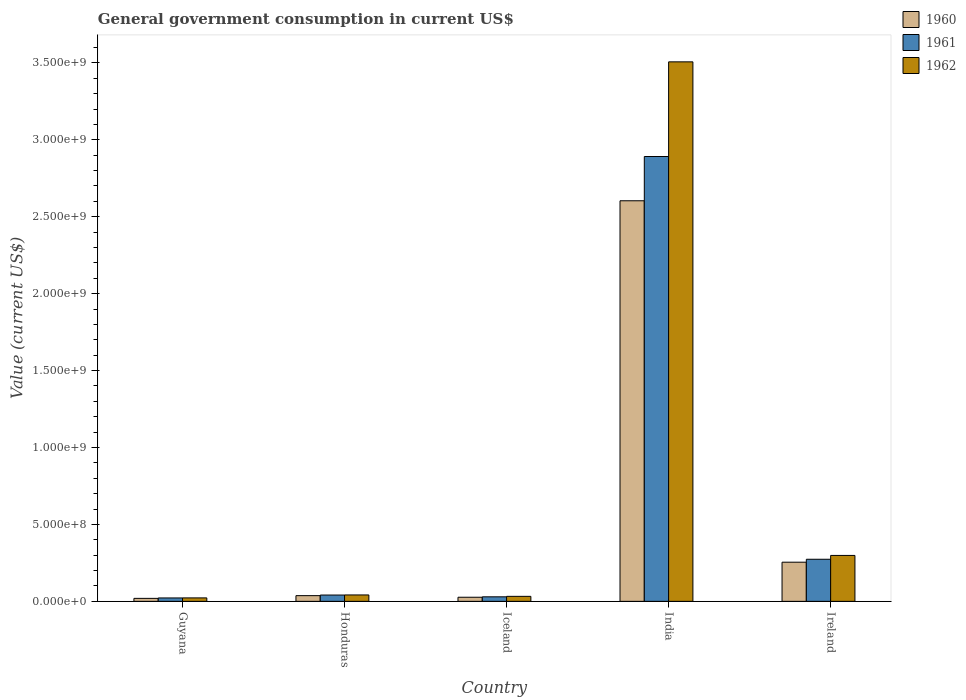How many different coloured bars are there?
Your answer should be compact. 3. Are the number of bars per tick equal to the number of legend labels?
Offer a terse response. Yes. How many bars are there on the 3rd tick from the left?
Your response must be concise. 3. How many bars are there on the 1st tick from the right?
Provide a succinct answer. 3. What is the government conusmption in 1961 in Ireland?
Your answer should be very brief. 2.74e+08. Across all countries, what is the maximum government conusmption in 1962?
Make the answer very short. 3.51e+09. Across all countries, what is the minimum government conusmption in 1962?
Your answer should be compact. 2.25e+07. In which country was the government conusmption in 1960 minimum?
Provide a succinct answer. Guyana. What is the total government conusmption in 1961 in the graph?
Keep it short and to the point. 3.26e+09. What is the difference between the government conusmption in 1961 in Iceland and that in India?
Your answer should be very brief. -2.86e+09. What is the difference between the government conusmption in 1961 in India and the government conusmption in 1960 in Honduras?
Keep it short and to the point. 2.85e+09. What is the average government conusmption in 1961 per country?
Your answer should be very brief. 6.52e+08. What is the difference between the government conusmption of/in 1960 and government conusmption of/in 1961 in Ireland?
Keep it short and to the point. -1.91e+07. In how many countries, is the government conusmption in 1960 greater than 2300000000 US$?
Provide a short and direct response. 1. What is the ratio of the government conusmption in 1962 in Iceland to that in India?
Keep it short and to the point. 0.01. Is the difference between the government conusmption in 1960 in Guyana and Iceland greater than the difference between the government conusmption in 1961 in Guyana and Iceland?
Give a very brief answer. Yes. What is the difference between the highest and the second highest government conusmption in 1962?
Provide a succinct answer. 2.57e+08. What is the difference between the highest and the lowest government conusmption in 1962?
Your answer should be very brief. 3.48e+09. Is the sum of the government conusmption in 1961 in Honduras and Ireland greater than the maximum government conusmption in 1960 across all countries?
Your answer should be very brief. No. What does the 3rd bar from the right in Ireland represents?
Your answer should be very brief. 1960. Is it the case that in every country, the sum of the government conusmption in 1961 and government conusmption in 1960 is greater than the government conusmption in 1962?
Provide a succinct answer. Yes. How many bars are there?
Offer a very short reply. 15. Are all the bars in the graph horizontal?
Provide a succinct answer. No. Are the values on the major ticks of Y-axis written in scientific E-notation?
Give a very brief answer. Yes. Does the graph contain grids?
Give a very brief answer. No. Where does the legend appear in the graph?
Provide a succinct answer. Top right. What is the title of the graph?
Give a very brief answer. General government consumption in current US$. What is the label or title of the X-axis?
Your response must be concise. Country. What is the label or title of the Y-axis?
Give a very brief answer. Value (current US$). What is the Value (current US$) of 1960 in Guyana?
Your answer should be very brief. 1.95e+07. What is the Value (current US$) in 1961 in Guyana?
Provide a succinct answer. 2.22e+07. What is the Value (current US$) in 1962 in Guyana?
Your answer should be compact. 2.25e+07. What is the Value (current US$) in 1960 in Honduras?
Your answer should be compact. 3.72e+07. What is the Value (current US$) in 1961 in Honduras?
Your answer should be very brief. 4.10e+07. What is the Value (current US$) of 1962 in Honduras?
Make the answer very short. 4.16e+07. What is the Value (current US$) in 1960 in Iceland?
Ensure brevity in your answer.  2.68e+07. What is the Value (current US$) of 1961 in Iceland?
Your answer should be very brief. 2.95e+07. What is the Value (current US$) of 1962 in Iceland?
Your answer should be compact. 3.25e+07. What is the Value (current US$) of 1960 in India?
Give a very brief answer. 2.60e+09. What is the Value (current US$) in 1961 in India?
Give a very brief answer. 2.89e+09. What is the Value (current US$) of 1962 in India?
Provide a succinct answer. 3.51e+09. What is the Value (current US$) in 1960 in Ireland?
Ensure brevity in your answer.  2.55e+08. What is the Value (current US$) of 1961 in Ireland?
Ensure brevity in your answer.  2.74e+08. What is the Value (current US$) in 1962 in Ireland?
Make the answer very short. 2.99e+08. Across all countries, what is the maximum Value (current US$) of 1960?
Give a very brief answer. 2.60e+09. Across all countries, what is the maximum Value (current US$) of 1961?
Ensure brevity in your answer.  2.89e+09. Across all countries, what is the maximum Value (current US$) of 1962?
Offer a very short reply. 3.51e+09. Across all countries, what is the minimum Value (current US$) in 1960?
Give a very brief answer. 1.95e+07. Across all countries, what is the minimum Value (current US$) in 1961?
Your answer should be very brief. 2.22e+07. Across all countries, what is the minimum Value (current US$) of 1962?
Your answer should be very brief. 2.25e+07. What is the total Value (current US$) of 1960 in the graph?
Give a very brief answer. 2.94e+09. What is the total Value (current US$) of 1961 in the graph?
Your answer should be very brief. 3.26e+09. What is the total Value (current US$) of 1962 in the graph?
Your answer should be compact. 3.90e+09. What is the difference between the Value (current US$) in 1960 in Guyana and that in Honduras?
Give a very brief answer. -1.77e+07. What is the difference between the Value (current US$) of 1961 in Guyana and that in Honduras?
Provide a succinct answer. -1.89e+07. What is the difference between the Value (current US$) in 1962 in Guyana and that in Honduras?
Give a very brief answer. -1.91e+07. What is the difference between the Value (current US$) of 1960 in Guyana and that in Iceland?
Your answer should be very brief. -7.28e+06. What is the difference between the Value (current US$) of 1961 in Guyana and that in Iceland?
Your answer should be very brief. -7.36e+06. What is the difference between the Value (current US$) in 1962 in Guyana and that in Iceland?
Your answer should be compact. -1.00e+07. What is the difference between the Value (current US$) of 1960 in Guyana and that in India?
Provide a short and direct response. -2.58e+09. What is the difference between the Value (current US$) in 1961 in Guyana and that in India?
Offer a very short reply. -2.87e+09. What is the difference between the Value (current US$) in 1962 in Guyana and that in India?
Provide a succinct answer. -3.48e+09. What is the difference between the Value (current US$) of 1960 in Guyana and that in Ireland?
Your answer should be compact. -2.35e+08. What is the difference between the Value (current US$) in 1961 in Guyana and that in Ireland?
Offer a terse response. -2.51e+08. What is the difference between the Value (current US$) of 1962 in Guyana and that in Ireland?
Provide a short and direct response. -2.76e+08. What is the difference between the Value (current US$) in 1960 in Honduras and that in Iceland?
Ensure brevity in your answer.  1.04e+07. What is the difference between the Value (current US$) in 1961 in Honduras and that in Iceland?
Keep it short and to the point. 1.15e+07. What is the difference between the Value (current US$) in 1962 in Honduras and that in Iceland?
Your answer should be compact. 9.12e+06. What is the difference between the Value (current US$) in 1960 in Honduras and that in India?
Offer a terse response. -2.57e+09. What is the difference between the Value (current US$) in 1961 in Honduras and that in India?
Make the answer very short. -2.85e+09. What is the difference between the Value (current US$) in 1962 in Honduras and that in India?
Keep it short and to the point. -3.47e+09. What is the difference between the Value (current US$) in 1960 in Honduras and that in Ireland?
Keep it short and to the point. -2.17e+08. What is the difference between the Value (current US$) in 1961 in Honduras and that in Ireland?
Your answer should be very brief. -2.33e+08. What is the difference between the Value (current US$) of 1962 in Honduras and that in Ireland?
Make the answer very short. -2.57e+08. What is the difference between the Value (current US$) in 1960 in Iceland and that in India?
Provide a short and direct response. -2.58e+09. What is the difference between the Value (current US$) of 1961 in Iceland and that in India?
Make the answer very short. -2.86e+09. What is the difference between the Value (current US$) in 1962 in Iceland and that in India?
Keep it short and to the point. -3.47e+09. What is the difference between the Value (current US$) of 1960 in Iceland and that in Ireland?
Your answer should be compact. -2.28e+08. What is the difference between the Value (current US$) of 1961 in Iceland and that in Ireland?
Provide a short and direct response. -2.44e+08. What is the difference between the Value (current US$) of 1962 in Iceland and that in Ireland?
Your answer should be compact. -2.66e+08. What is the difference between the Value (current US$) in 1960 in India and that in Ireland?
Make the answer very short. 2.35e+09. What is the difference between the Value (current US$) in 1961 in India and that in Ireland?
Your answer should be compact. 2.62e+09. What is the difference between the Value (current US$) in 1962 in India and that in Ireland?
Your answer should be very brief. 3.21e+09. What is the difference between the Value (current US$) of 1960 in Guyana and the Value (current US$) of 1961 in Honduras?
Your answer should be compact. -2.16e+07. What is the difference between the Value (current US$) in 1960 in Guyana and the Value (current US$) in 1962 in Honduras?
Your response must be concise. -2.22e+07. What is the difference between the Value (current US$) in 1961 in Guyana and the Value (current US$) in 1962 in Honduras?
Make the answer very short. -1.95e+07. What is the difference between the Value (current US$) of 1960 in Guyana and the Value (current US$) of 1961 in Iceland?
Provide a short and direct response. -1.00e+07. What is the difference between the Value (current US$) in 1960 in Guyana and the Value (current US$) in 1962 in Iceland?
Your answer should be compact. -1.30e+07. What is the difference between the Value (current US$) of 1961 in Guyana and the Value (current US$) of 1962 in Iceland?
Offer a very short reply. -1.04e+07. What is the difference between the Value (current US$) of 1960 in Guyana and the Value (current US$) of 1961 in India?
Provide a short and direct response. -2.87e+09. What is the difference between the Value (current US$) of 1960 in Guyana and the Value (current US$) of 1962 in India?
Provide a succinct answer. -3.49e+09. What is the difference between the Value (current US$) of 1961 in Guyana and the Value (current US$) of 1962 in India?
Your answer should be compact. -3.48e+09. What is the difference between the Value (current US$) in 1960 in Guyana and the Value (current US$) in 1961 in Ireland?
Ensure brevity in your answer.  -2.54e+08. What is the difference between the Value (current US$) of 1960 in Guyana and the Value (current US$) of 1962 in Ireland?
Provide a short and direct response. -2.79e+08. What is the difference between the Value (current US$) of 1961 in Guyana and the Value (current US$) of 1962 in Ireland?
Offer a very short reply. -2.76e+08. What is the difference between the Value (current US$) of 1960 in Honduras and the Value (current US$) of 1961 in Iceland?
Give a very brief answer. 7.62e+06. What is the difference between the Value (current US$) in 1960 in Honduras and the Value (current US$) in 1962 in Iceland?
Your response must be concise. 4.62e+06. What is the difference between the Value (current US$) in 1961 in Honduras and the Value (current US$) in 1962 in Iceland?
Offer a terse response. 8.52e+06. What is the difference between the Value (current US$) of 1960 in Honduras and the Value (current US$) of 1961 in India?
Give a very brief answer. -2.85e+09. What is the difference between the Value (current US$) of 1960 in Honduras and the Value (current US$) of 1962 in India?
Your response must be concise. -3.47e+09. What is the difference between the Value (current US$) in 1961 in Honduras and the Value (current US$) in 1962 in India?
Give a very brief answer. -3.47e+09. What is the difference between the Value (current US$) in 1960 in Honduras and the Value (current US$) in 1961 in Ireland?
Offer a very short reply. -2.37e+08. What is the difference between the Value (current US$) in 1960 in Honduras and the Value (current US$) in 1962 in Ireland?
Give a very brief answer. -2.61e+08. What is the difference between the Value (current US$) in 1961 in Honduras and the Value (current US$) in 1962 in Ireland?
Your answer should be very brief. -2.58e+08. What is the difference between the Value (current US$) in 1960 in Iceland and the Value (current US$) in 1961 in India?
Your answer should be very brief. -2.86e+09. What is the difference between the Value (current US$) in 1960 in Iceland and the Value (current US$) in 1962 in India?
Keep it short and to the point. -3.48e+09. What is the difference between the Value (current US$) in 1961 in Iceland and the Value (current US$) in 1962 in India?
Keep it short and to the point. -3.48e+09. What is the difference between the Value (current US$) of 1960 in Iceland and the Value (current US$) of 1961 in Ireland?
Ensure brevity in your answer.  -2.47e+08. What is the difference between the Value (current US$) of 1960 in Iceland and the Value (current US$) of 1962 in Ireland?
Your answer should be very brief. -2.72e+08. What is the difference between the Value (current US$) in 1961 in Iceland and the Value (current US$) in 1962 in Ireland?
Your answer should be compact. -2.69e+08. What is the difference between the Value (current US$) of 1960 in India and the Value (current US$) of 1961 in Ireland?
Give a very brief answer. 2.33e+09. What is the difference between the Value (current US$) in 1960 in India and the Value (current US$) in 1962 in Ireland?
Your answer should be very brief. 2.31e+09. What is the difference between the Value (current US$) of 1961 in India and the Value (current US$) of 1962 in Ireland?
Ensure brevity in your answer.  2.59e+09. What is the average Value (current US$) of 1960 per country?
Keep it short and to the point. 5.88e+08. What is the average Value (current US$) of 1961 per country?
Provide a succinct answer. 6.52e+08. What is the average Value (current US$) of 1962 per country?
Your response must be concise. 7.80e+08. What is the difference between the Value (current US$) in 1960 and Value (current US$) in 1961 in Guyana?
Provide a short and direct response. -2.68e+06. What is the difference between the Value (current US$) in 1960 and Value (current US$) in 1962 in Guyana?
Offer a very short reply. -3.03e+06. What is the difference between the Value (current US$) in 1961 and Value (current US$) in 1962 in Guyana?
Offer a very short reply. -3.50e+05. What is the difference between the Value (current US$) of 1960 and Value (current US$) of 1961 in Honduras?
Offer a terse response. -3.90e+06. What is the difference between the Value (current US$) in 1960 and Value (current US$) in 1962 in Honduras?
Keep it short and to the point. -4.50e+06. What is the difference between the Value (current US$) of 1961 and Value (current US$) of 1962 in Honduras?
Offer a terse response. -6.00e+05. What is the difference between the Value (current US$) in 1960 and Value (current US$) in 1961 in Iceland?
Provide a short and direct response. -2.77e+06. What is the difference between the Value (current US$) in 1960 and Value (current US$) in 1962 in Iceland?
Keep it short and to the point. -5.77e+06. What is the difference between the Value (current US$) in 1961 and Value (current US$) in 1962 in Iceland?
Ensure brevity in your answer.  -3.00e+06. What is the difference between the Value (current US$) in 1960 and Value (current US$) in 1961 in India?
Offer a terse response. -2.88e+08. What is the difference between the Value (current US$) in 1960 and Value (current US$) in 1962 in India?
Keep it short and to the point. -9.03e+08. What is the difference between the Value (current US$) in 1961 and Value (current US$) in 1962 in India?
Offer a very short reply. -6.15e+08. What is the difference between the Value (current US$) in 1960 and Value (current US$) in 1961 in Ireland?
Offer a terse response. -1.91e+07. What is the difference between the Value (current US$) of 1960 and Value (current US$) of 1962 in Ireland?
Your answer should be very brief. -4.40e+07. What is the difference between the Value (current US$) of 1961 and Value (current US$) of 1962 in Ireland?
Your response must be concise. -2.49e+07. What is the ratio of the Value (current US$) in 1960 in Guyana to that in Honduras?
Your answer should be compact. 0.52. What is the ratio of the Value (current US$) of 1961 in Guyana to that in Honduras?
Offer a very short reply. 0.54. What is the ratio of the Value (current US$) of 1962 in Guyana to that in Honduras?
Your answer should be compact. 0.54. What is the ratio of the Value (current US$) in 1960 in Guyana to that in Iceland?
Provide a succinct answer. 0.73. What is the ratio of the Value (current US$) in 1961 in Guyana to that in Iceland?
Your answer should be very brief. 0.75. What is the ratio of the Value (current US$) of 1962 in Guyana to that in Iceland?
Offer a terse response. 0.69. What is the ratio of the Value (current US$) in 1960 in Guyana to that in India?
Your answer should be compact. 0.01. What is the ratio of the Value (current US$) of 1961 in Guyana to that in India?
Keep it short and to the point. 0.01. What is the ratio of the Value (current US$) in 1962 in Guyana to that in India?
Ensure brevity in your answer.  0.01. What is the ratio of the Value (current US$) in 1960 in Guyana to that in Ireland?
Make the answer very short. 0.08. What is the ratio of the Value (current US$) of 1961 in Guyana to that in Ireland?
Your answer should be very brief. 0.08. What is the ratio of the Value (current US$) in 1962 in Guyana to that in Ireland?
Provide a short and direct response. 0.08. What is the ratio of the Value (current US$) in 1960 in Honduras to that in Iceland?
Your answer should be very brief. 1.39. What is the ratio of the Value (current US$) of 1961 in Honduras to that in Iceland?
Offer a terse response. 1.39. What is the ratio of the Value (current US$) in 1962 in Honduras to that in Iceland?
Offer a terse response. 1.28. What is the ratio of the Value (current US$) of 1960 in Honduras to that in India?
Your answer should be very brief. 0.01. What is the ratio of the Value (current US$) of 1961 in Honduras to that in India?
Keep it short and to the point. 0.01. What is the ratio of the Value (current US$) in 1962 in Honduras to that in India?
Make the answer very short. 0.01. What is the ratio of the Value (current US$) of 1960 in Honduras to that in Ireland?
Provide a succinct answer. 0.15. What is the ratio of the Value (current US$) of 1961 in Honduras to that in Ireland?
Give a very brief answer. 0.15. What is the ratio of the Value (current US$) of 1962 in Honduras to that in Ireland?
Provide a succinct answer. 0.14. What is the ratio of the Value (current US$) in 1960 in Iceland to that in India?
Offer a very short reply. 0.01. What is the ratio of the Value (current US$) of 1961 in Iceland to that in India?
Provide a succinct answer. 0.01. What is the ratio of the Value (current US$) of 1962 in Iceland to that in India?
Provide a short and direct response. 0.01. What is the ratio of the Value (current US$) in 1960 in Iceland to that in Ireland?
Your answer should be very brief. 0.11. What is the ratio of the Value (current US$) of 1961 in Iceland to that in Ireland?
Make the answer very short. 0.11. What is the ratio of the Value (current US$) in 1962 in Iceland to that in Ireland?
Give a very brief answer. 0.11. What is the ratio of the Value (current US$) of 1960 in India to that in Ireland?
Provide a succinct answer. 10.23. What is the ratio of the Value (current US$) of 1961 in India to that in Ireland?
Offer a terse response. 10.57. What is the ratio of the Value (current US$) in 1962 in India to that in Ireland?
Your answer should be very brief. 11.75. What is the difference between the highest and the second highest Value (current US$) in 1960?
Keep it short and to the point. 2.35e+09. What is the difference between the highest and the second highest Value (current US$) in 1961?
Your answer should be very brief. 2.62e+09. What is the difference between the highest and the second highest Value (current US$) of 1962?
Your answer should be very brief. 3.21e+09. What is the difference between the highest and the lowest Value (current US$) of 1960?
Keep it short and to the point. 2.58e+09. What is the difference between the highest and the lowest Value (current US$) in 1961?
Offer a terse response. 2.87e+09. What is the difference between the highest and the lowest Value (current US$) of 1962?
Provide a short and direct response. 3.48e+09. 